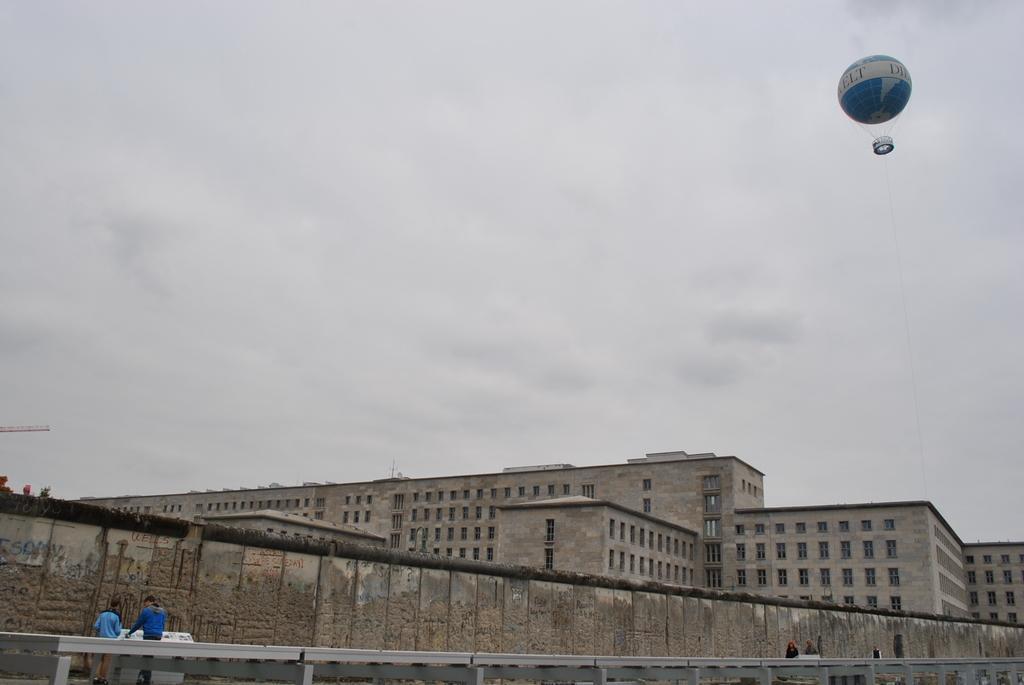Please provide a concise description of this image. In this picture there are two persons standing in front of a white color object and there is a crane in the left corner and there is a balloon attached to a rope in the right corner and there is a fence wall and a building in the background and the sky is cloudy. 